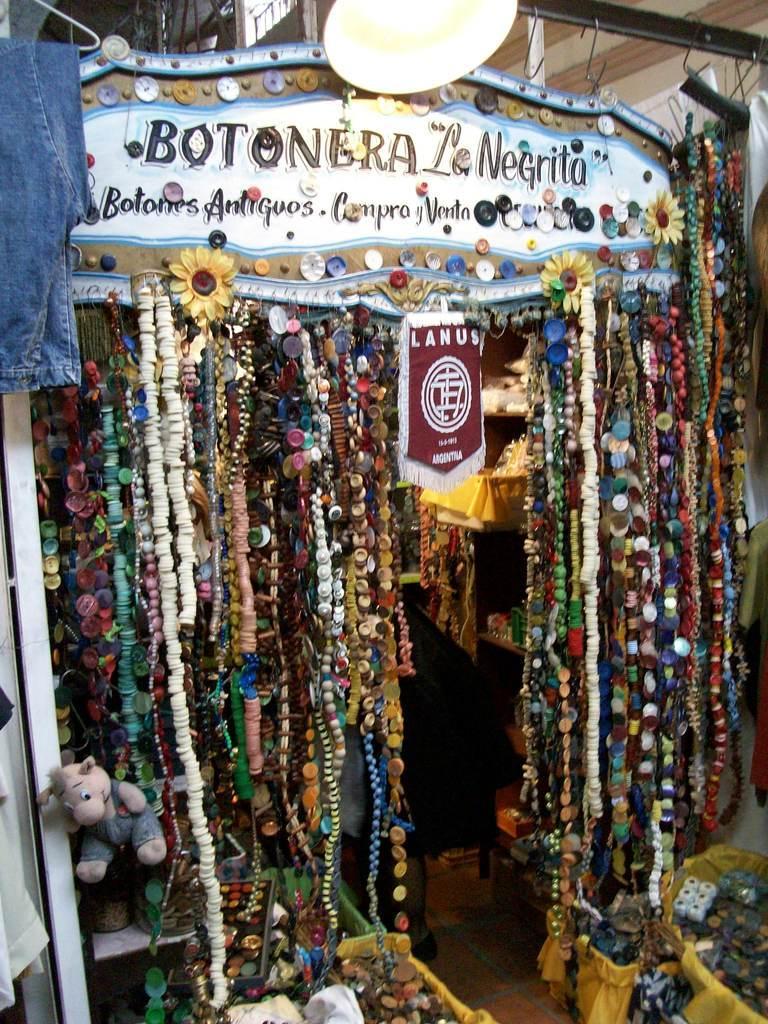Can you describe this image briefly? In this picture I can see number of things in front which are colorful and I see the board on the top on which there is something written and I see the light on the top and on the left bottom I see a soft toy. 